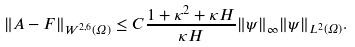<formula> <loc_0><loc_0><loc_500><loc_500>\| { A } - { F } \| _ { W ^ { 2 , 6 } ( \Omega ) } \leq C \frac { 1 + \kappa ^ { 2 } + \kappa H } { \kappa H } \| \psi \| _ { \infty } \| \psi \| _ { L ^ { 2 } ( \Omega ) } .</formula> 